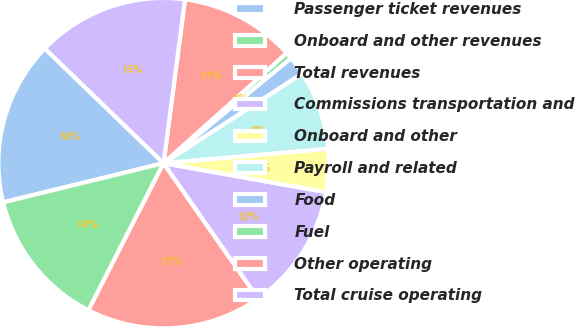Convert chart to OTSL. <chart><loc_0><loc_0><loc_500><loc_500><pie_chart><fcel>Passenger ticket revenues<fcel>Onboard and other revenues<fcel>Total revenues<fcel>Commissions transportation and<fcel>Onboard and other<fcel>Payroll and related<fcel>Food<fcel>Fuel<fcel>Other operating<fcel>Total cruise operating<nl><fcel>16.04%<fcel>13.67%<fcel>17.22%<fcel>12.49%<fcel>4.2%<fcel>7.75%<fcel>1.83%<fcel>0.65%<fcel>11.3%<fcel>14.85%<nl></chart> 